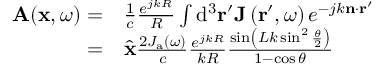Convert formula to latex. <formula><loc_0><loc_0><loc_500><loc_500>\begin{array} { r l } { A ( x , \omega ) = } & { \frac { 1 } { c } \frac { e ^ { j k R } } { R } \int d ^ { 3 } r ^ { \prime } J \left ( r ^ { \prime } , \omega \right ) e ^ { - j k n \cdot r ^ { \prime } } } \\ { = } & { { \hat { x } } \frac { 2 J _ { a } ( \omega ) } { c } \frac { e ^ { j k R } } { k R } \frac { \sin \left ( L k \sin ^ { 2 } \frac { \theta } { 2 } \right ) } { 1 - \cos \theta } } \end{array}</formula> 